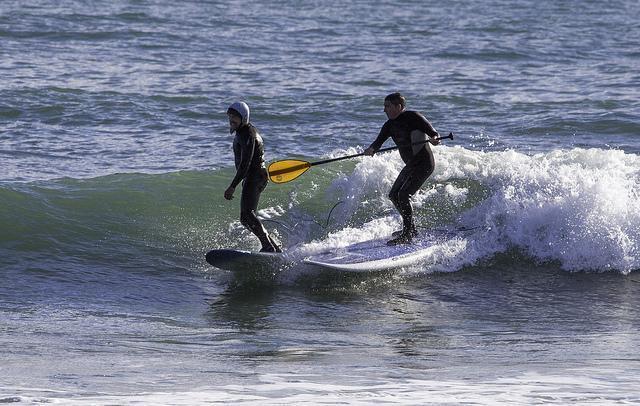How many of these people are holding a paddle?
Give a very brief answer. 1. How many people are in the water?
Give a very brief answer. 2. How many people are in the picture?
Give a very brief answer. 2. How many people can be seen?
Give a very brief answer. 2. 